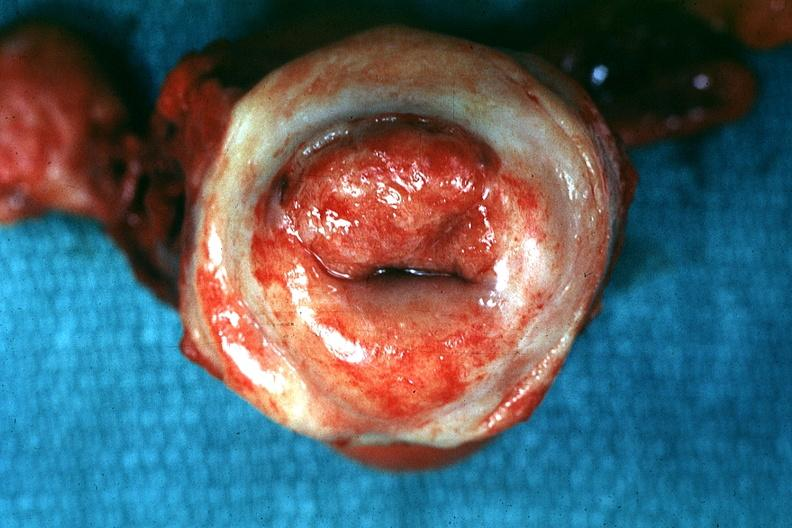what said to be invasive carcinoma?
Answer the question using a single word or phrase. Inflamed exocervix 